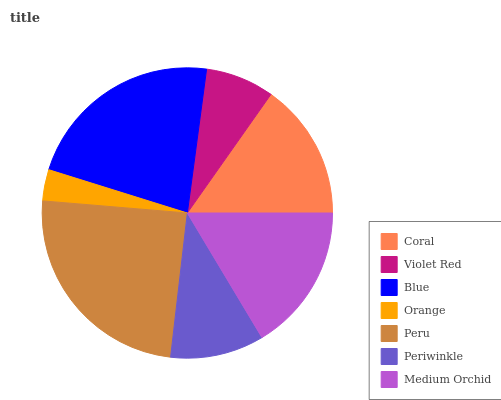Is Orange the minimum?
Answer yes or no. Yes. Is Peru the maximum?
Answer yes or no. Yes. Is Violet Red the minimum?
Answer yes or no. No. Is Violet Red the maximum?
Answer yes or no. No. Is Coral greater than Violet Red?
Answer yes or no. Yes. Is Violet Red less than Coral?
Answer yes or no. Yes. Is Violet Red greater than Coral?
Answer yes or no. No. Is Coral less than Violet Red?
Answer yes or no. No. Is Coral the high median?
Answer yes or no. Yes. Is Coral the low median?
Answer yes or no. Yes. Is Orange the high median?
Answer yes or no. No. Is Blue the low median?
Answer yes or no. No. 